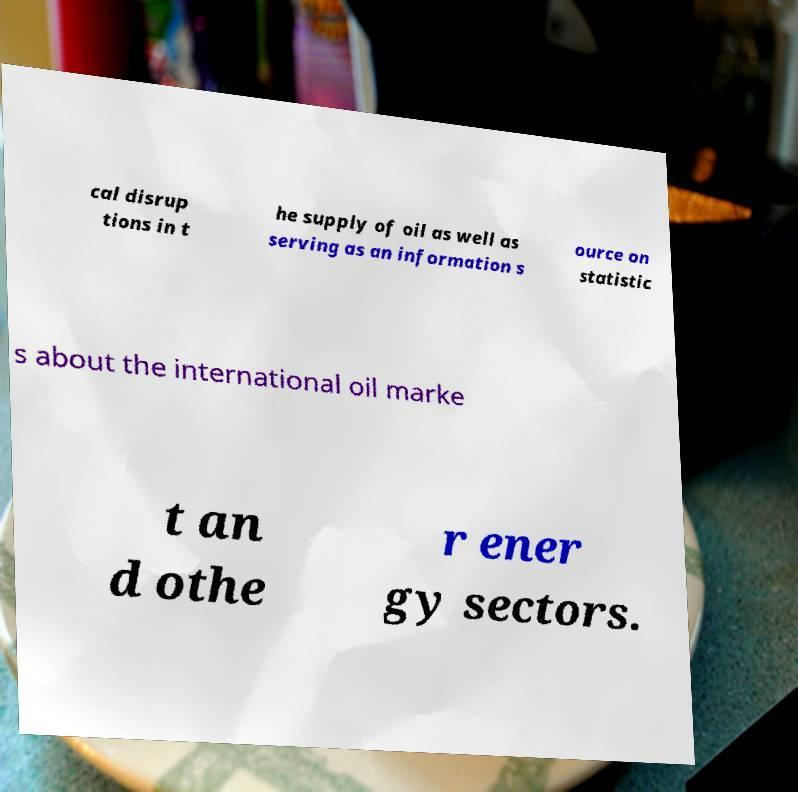Could you assist in decoding the text presented in this image and type it out clearly? cal disrup tions in t he supply of oil as well as serving as an information s ource on statistic s about the international oil marke t an d othe r ener gy sectors. 